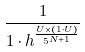Convert formula to latex. <formula><loc_0><loc_0><loc_500><loc_500>\frac { 1 } { 1 \cdot h ^ { \frac { U \times ( 1 \cdot U ) } { 5 ^ { N + 1 } } } }</formula> 